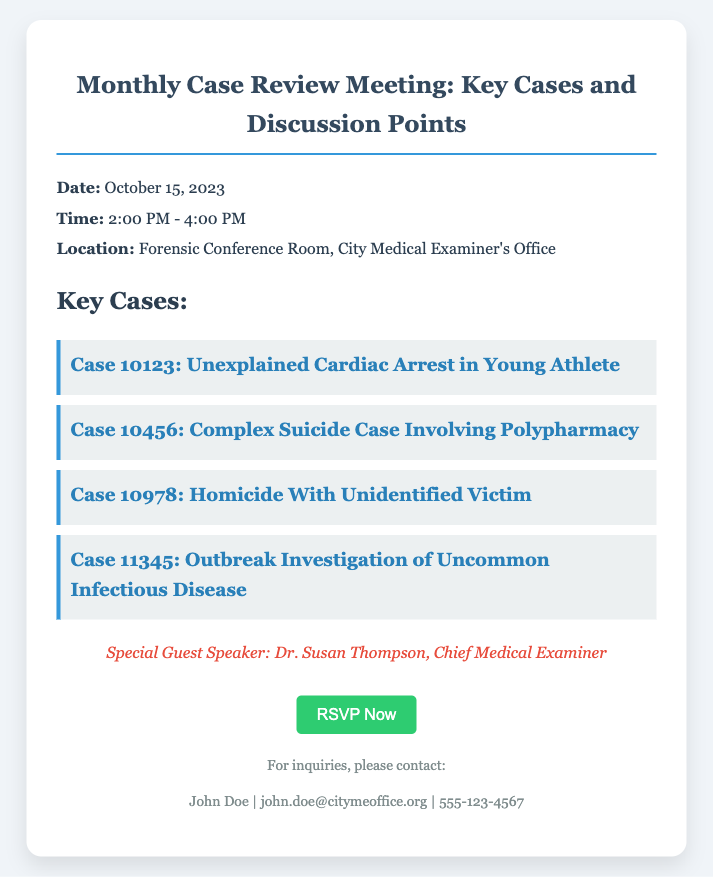What is the date of the meeting? The date of the meeting is explicitly mentioned in the document, which states "Date: October 15, 2023."
Answer: October 15, 2023 What time does the meeting start? The starting time is provided in the document: "Time: 2:00 PM - 4:00 PM," indicating when the meeting begins.
Answer: 2:00 PM Who is the special guest speaker? The document identifies the special guest speaker as "Dr. Susan Thompson, Chief Medical Examiner," who is highlighted in the guest section.
Answer: Dr. Susan Thompson How many key cases are listed? The document presents a section titled "Key Cases" that lists the number of cases discussed, totaling four cases.
Answer: 4 What is the location of the meeting? The document specifies the location as "Forensic Conference Room, City Medical Examiner's Office," which is where the meeting will take place.
Answer: Forensic Conference Room, City Medical Examiner's Office Which case involves an outbreak investigation? The document lists cases, and the one involving an outbreak investigation is "Case 11345: Outbreak Investigation of Uncommon Infectious Disease."
Answer: Case 11345: Outbreak Investigation of Uncommon Infectious Disease What is the contact email provided? The document contains contact information, including an email address: "john.doe@citymeoffice.org," for inquiries related to the meeting.
Answer: john.doe@citymeoffice.org What kind of cases will be discussed at the meeting? The document outlines that key cases are related to unexplained cardiac arrest, complex suicide, homicide, and infectious disease, indicating the topics of discussion.
Answer: Unexplained cardiac arrest, complex suicide, homicide, and infectious disease 